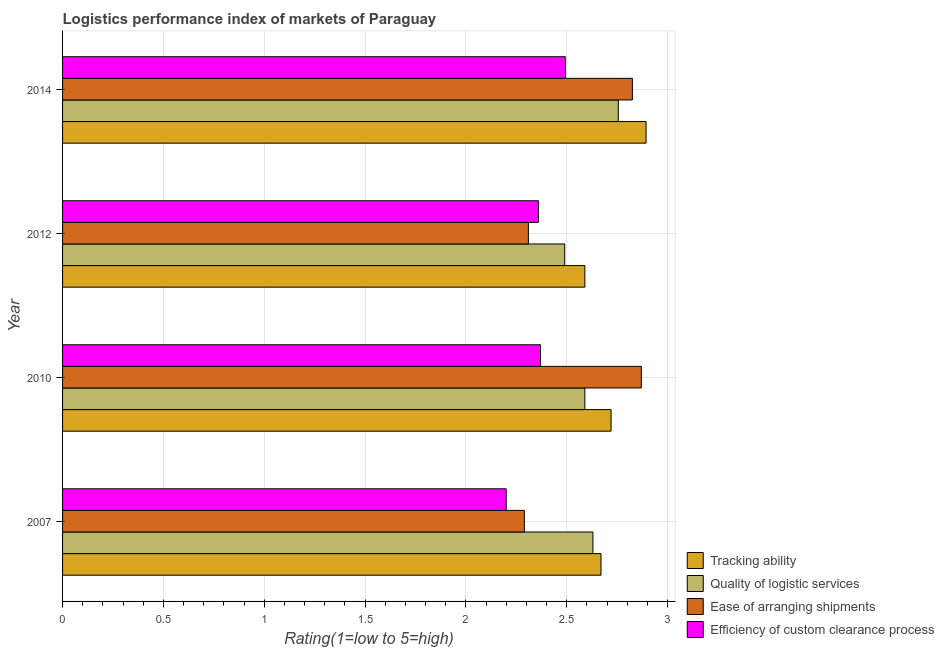How many different coloured bars are there?
Your answer should be compact. 4. Are the number of bars on each tick of the Y-axis equal?
Give a very brief answer. Yes. How many bars are there on the 3rd tick from the top?
Offer a very short reply. 4. How many bars are there on the 2nd tick from the bottom?
Your answer should be compact. 4. What is the label of the 4th group of bars from the top?
Ensure brevity in your answer.  2007. What is the lpi rating of quality of logistic services in 2014?
Your response must be concise. 2.76. Across all years, what is the maximum lpi rating of tracking ability?
Your answer should be very brief. 2.89. Across all years, what is the minimum lpi rating of ease of arranging shipments?
Give a very brief answer. 2.29. In which year was the lpi rating of quality of logistic services minimum?
Give a very brief answer. 2012. What is the total lpi rating of quality of logistic services in the graph?
Your response must be concise. 10.47. What is the difference between the lpi rating of ease of arranging shipments in 2012 and that in 2014?
Your answer should be very brief. -0.52. What is the difference between the lpi rating of quality of logistic services in 2012 and the lpi rating of ease of arranging shipments in 2007?
Make the answer very short. 0.2. What is the average lpi rating of tracking ability per year?
Your response must be concise. 2.72. In the year 2012, what is the difference between the lpi rating of ease of arranging shipments and lpi rating of quality of logistic services?
Your response must be concise. -0.18. In how many years, is the lpi rating of ease of arranging shipments greater than 0.30000000000000004 ?
Your answer should be compact. 4. What is the ratio of the lpi rating of ease of arranging shipments in 2007 to that in 2014?
Give a very brief answer. 0.81. Is the difference between the lpi rating of tracking ability in 2007 and 2012 greater than the difference between the lpi rating of ease of arranging shipments in 2007 and 2012?
Provide a succinct answer. Yes. What is the difference between the highest and the second highest lpi rating of tracking ability?
Your answer should be very brief. 0.17. What is the difference between the highest and the lowest lpi rating of ease of arranging shipments?
Provide a succinct answer. 0.58. In how many years, is the lpi rating of ease of arranging shipments greater than the average lpi rating of ease of arranging shipments taken over all years?
Give a very brief answer. 2. Is it the case that in every year, the sum of the lpi rating of ease of arranging shipments and lpi rating of efficiency of custom clearance process is greater than the sum of lpi rating of quality of logistic services and lpi rating of tracking ability?
Your response must be concise. No. What does the 4th bar from the top in 2010 represents?
Ensure brevity in your answer.  Tracking ability. What does the 1st bar from the bottom in 2012 represents?
Provide a short and direct response. Tracking ability. How many bars are there?
Give a very brief answer. 16. Are all the bars in the graph horizontal?
Your answer should be very brief. Yes. How many years are there in the graph?
Your answer should be very brief. 4. How many legend labels are there?
Make the answer very short. 4. What is the title of the graph?
Ensure brevity in your answer.  Logistics performance index of markets of Paraguay. Does "Regional development banks" appear as one of the legend labels in the graph?
Your response must be concise. No. What is the label or title of the X-axis?
Give a very brief answer. Rating(1=low to 5=high). What is the label or title of the Y-axis?
Provide a succinct answer. Year. What is the Rating(1=low to 5=high) in Tracking ability in 2007?
Offer a very short reply. 2.67. What is the Rating(1=low to 5=high) in Quality of logistic services in 2007?
Offer a very short reply. 2.63. What is the Rating(1=low to 5=high) of Ease of arranging shipments in 2007?
Make the answer very short. 2.29. What is the Rating(1=low to 5=high) in Tracking ability in 2010?
Offer a terse response. 2.72. What is the Rating(1=low to 5=high) in Quality of logistic services in 2010?
Give a very brief answer. 2.59. What is the Rating(1=low to 5=high) in Ease of arranging shipments in 2010?
Your answer should be compact. 2.87. What is the Rating(1=low to 5=high) in Efficiency of custom clearance process in 2010?
Ensure brevity in your answer.  2.37. What is the Rating(1=low to 5=high) of Tracking ability in 2012?
Offer a very short reply. 2.59. What is the Rating(1=low to 5=high) of Quality of logistic services in 2012?
Offer a terse response. 2.49. What is the Rating(1=low to 5=high) of Ease of arranging shipments in 2012?
Make the answer very short. 2.31. What is the Rating(1=low to 5=high) of Efficiency of custom clearance process in 2012?
Make the answer very short. 2.36. What is the Rating(1=low to 5=high) of Tracking ability in 2014?
Your answer should be very brief. 2.89. What is the Rating(1=low to 5=high) of Quality of logistic services in 2014?
Your answer should be compact. 2.76. What is the Rating(1=low to 5=high) of Ease of arranging shipments in 2014?
Your response must be concise. 2.83. What is the Rating(1=low to 5=high) of Efficiency of custom clearance process in 2014?
Offer a terse response. 2.49. Across all years, what is the maximum Rating(1=low to 5=high) in Tracking ability?
Give a very brief answer. 2.89. Across all years, what is the maximum Rating(1=low to 5=high) in Quality of logistic services?
Give a very brief answer. 2.76. Across all years, what is the maximum Rating(1=low to 5=high) in Ease of arranging shipments?
Provide a succinct answer. 2.87. Across all years, what is the maximum Rating(1=low to 5=high) of Efficiency of custom clearance process?
Provide a short and direct response. 2.49. Across all years, what is the minimum Rating(1=low to 5=high) of Tracking ability?
Provide a short and direct response. 2.59. Across all years, what is the minimum Rating(1=low to 5=high) of Quality of logistic services?
Your answer should be very brief. 2.49. Across all years, what is the minimum Rating(1=low to 5=high) of Ease of arranging shipments?
Provide a succinct answer. 2.29. Across all years, what is the minimum Rating(1=low to 5=high) in Efficiency of custom clearance process?
Keep it short and to the point. 2.2. What is the total Rating(1=low to 5=high) of Tracking ability in the graph?
Offer a very short reply. 10.87. What is the total Rating(1=low to 5=high) of Quality of logistic services in the graph?
Ensure brevity in your answer.  10.47. What is the total Rating(1=low to 5=high) of Ease of arranging shipments in the graph?
Provide a succinct answer. 10.3. What is the total Rating(1=low to 5=high) of Efficiency of custom clearance process in the graph?
Ensure brevity in your answer.  9.42. What is the difference between the Rating(1=low to 5=high) of Tracking ability in 2007 and that in 2010?
Provide a succinct answer. -0.05. What is the difference between the Rating(1=low to 5=high) of Quality of logistic services in 2007 and that in 2010?
Give a very brief answer. 0.04. What is the difference between the Rating(1=low to 5=high) in Ease of arranging shipments in 2007 and that in 2010?
Offer a very short reply. -0.58. What is the difference between the Rating(1=low to 5=high) of Efficiency of custom clearance process in 2007 and that in 2010?
Your response must be concise. -0.17. What is the difference between the Rating(1=low to 5=high) of Quality of logistic services in 2007 and that in 2012?
Offer a terse response. 0.14. What is the difference between the Rating(1=low to 5=high) of Ease of arranging shipments in 2007 and that in 2012?
Offer a very short reply. -0.02. What is the difference between the Rating(1=low to 5=high) in Efficiency of custom clearance process in 2007 and that in 2012?
Your answer should be very brief. -0.16. What is the difference between the Rating(1=low to 5=high) of Tracking ability in 2007 and that in 2014?
Your answer should be very brief. -0.22. What is the difference between the Rating(1=low to 5=high) of Quality of logistic services in 2007 and that in 2014?
Your answer should be very brief. -0.13. What is the difference between the Rating(1=low to 5=high) of Ease of arranging shipments in 2007 and that in 2014?
Give a very brief answer. -0.54. What is the difference between the Rating(1=low to 5=high) of Efficiency of custom clearance process in 2007 and that in 2014?
Provide a short and direct response. -0.29. What is the difference between the Rating(1=low to 5=high) of Tracking ability in 2010 and that in 2012?
Offer a very short reply. 0.13. What is the difference between the Rating(1=low to 5=high) of Ease of arranging shipments in 2010 and that in 2012?
Provide a succinct answer. 0.56. What is the difference between the Rating(1=low to 5=high) of Tracking ability in 2010 and that in 2014?
Provide a short and direct response. -0.17. What is the difference between the Rating(1=low to 5=high) of Quality of logistic services in 2010 and that in 2014?
Make the answer very short. -0.17. What is the difference between the Rating(1=low to 5=high) of Ease of arranging shipments in 2010 and that in 2014?
Provide a succinct answer. 0.04. What is the difference between the Rating(1=low to 5=high) of Efficiency of custom clearance process in 2010 and that in 2014?
Keep it short and to the point. -0.12. What is the difference between the Rating(1=low to 5=high) in Tracking ability in 2012 and that in 2014?
Keep it short and to the point. -0.3. What is the difference between the Rating(1=low to 5=high) in Quality of logistic services in 2012 and that in 2014?
Provide a succinct answer. -0.27. What is the difference between the Rating(1=low to 5=high) of Ease of arranging shipments in 2012 and that in 2014?
Offer a very short reply. -0.52. What is the difference between the Rating(1=low to 5=high) of Efficiency of custom clearance process in 2012 and that in 2014?
Provide a succinct answer. -0.13. What is the difference between the Rating(1=low to 5=high) of Tracking ability in 2007 and the Rating(1=low to 5=high) of Quality of logistic services in 2010?
Give a very brief answer. 0.08. What is the difference between the Rating(1=low to 5=high) of Quality of logistic services in 2007 and the Rating(1=low to 5=high) of Ease of arranging shipments in 2010?
Provide a succinct answer. -0.24. What is the difference between the Rating(1=low to 5=high) in Quality of logistic services in 2007 and the Rating(1=low to 5=high) in Efficiency of custom clearance process in 2010?
Provide a succinct answer. 0.26. What is the difference between the Rating(1=low to 5=high) of Ease of arranging shipments in 2007 and the Rating(1=low to 5=high) of Efficiency of custom clearance process in 2010?
Provide a short and direct response. -0.08. What is the difference between the Rating(1=low to 5=high) in Tracking ability in 2007 and the Rating(1=low to 5=high) in Quality of logistic services in 2012?
Keep it short and to the point. 0.18. What is the difference between the Rating(1=low to 5=high) in Tracking ability in 2007 and the Rating(1=low to 5=high) in Ease of arranging shipments in 2012?
Your answer should be very brief. 0.36. What is the difference between the Rating(1=low to 5=high) of Tracking ability in 2007 and the Rating(1=low to 5=high) of Efficiency of custom clearance process in 2012?
Provide a succinct answer. 0.31. What is the difference between the Rating(1=low to 5=high) of Quality of logistic services in 2007 and the Rating(1=low to 5=high) of Ease of arranging shipments in 2012?
Make the answer very short. 0.32. What is the difference between the Rating(1=low to 5=high) of Quality of logistic services in 2007 and the Rating(1=low to 5=high) of Efficiency of custom clearance process in 2012?
Ensure brevity in your answer.  0.27. What is the difference between the Rating(1=low to 5=high) in Ease of arranging shipments in 2007 and the Rating(1=low to 5=high) in Efficiency of custom clearance process in 2012?
Provide a succinct answer. -0.07. What is the difference between the Rating(1=low to 5=high) in Tracking ability in 2007 and the Rating(1=low to 5=high) in Quality of logistic services in 2014?
Give a very brief answer. -0.09. What is the difference between the Rating(1=low to 5=high) of Tracking ability in 2007 and the Rating(1=low to 5=high) of Ease of arranging shipments in 2014?
Offer a terse response. -0.16. What is the difference between the Rating(1=low to 5=high) of Tracking ability in 2007 and the Rating(1=low to 5=high) of Efficiency of custom clearance process in 2014?
Offer a very short reply. 0.18. What is the difference between the Rating(1=low to 5=high) in Quality of logistic services in 2007 and the Rating(1=low to 5=high) in Ease of arranging shipments in 2014?
Offer a terse response. -0.2. What is the difference between the Rating(1=low to 5=high) in Quality of logistic services in 2007 and the Rating(1=low to 5=high) in Efficiency of custom clearance process in 2014?
Provide a short and direct response. 0.14. What is the difference between the Rating(1=low to 5=high) in Ease of arranging shipments in 2007 and the Rating(1=low to 5=high) in Efficiency of custom clearance process in 2014?
Your answer should be very brief. -0.2. What is the difference between the Rating(1=low to 5=high) of Tracking ability in 2010 and the Rating(1=low to 5=high) of Quality of logistic services in 2012?
Provide a succinct answer. 0.23. What is the difference between the Rating(1=low to 5=high) in Tracking ability in 2010 and the Rating(1=low to 5=high) in Ease of arranging shipments in 2012?
Make the answer very short. 0.41. What is the difference between the Rating(1=low to 5=high) of Tracking ability in 2010 and the Rating(1=low to 5=high) of Efficiency of custom clearance process in 2012?
Offer a terse response. 0.36. What is the difference between the Rating(1=low to 5=high) in Quality of logistic services in 2010 and the Rating(1=low to 5=high) in Ease of arranging shipments in 2012?
Keep it short and to the point. 0.28. What is the difference between the Rating(1=low to 5=high) in Quality of logistic services in 2010 and the Rating(1=low to 5=high) in Efficiency of custom clearance process in 2012?
Keep it short and to the point. 0.23. What is the difference between the Rating(1=low to 5=high) of Ease of arranging shipments in 2010 and the Rating(1=low to 5=high) of Efficiency of custom clearance process in 2012?
Your answer should be compact. 0.51. What is the difference between the Rating(1=low to 5=high) in Tracking ability in 2010 and the Rating(1=low to 5=high) in Quality of logistic services in 2014?
Ensure brevity in your answer.  -0.04. What is the difference between the Rating(1=low to 5=high) in Tracking ability in 2010 and the Rating(1=low to 5=high) in Ease of arranging shipments in 2014?
Offer a terse response. -0.11. What is the difference between the Rating(1=low to 5=high) of Tracking ability in 2010 and the Rating(1=low to 5=high) of Efficiency of custom clearance process in 2014?
Offer a very short reply. 0.23. What is the difference between the Rating(1=low to 5=high) in Quality of logistic services in 2010 and the Rating(1=low to 5=high) in Ease of arranging shipments in 2014?
Give a very brief answer. -0.24. What is the difference between the Rating(1=low to 5=high) of Quality of logistic services in 2010 and the Rating(1=low to 5=high) of Efficiency of custom clearance process in 2014?
Provide a succinct answer. 0.1. What is the difference between the Rating(1=low to 5=high) of Ease of arranging shipments in 2010 and the Rating(1=low to 5=high) of Efficiency of custom clearance process in 2014?
Your response must be concise. 0.38. What is the difference between the Rating(1=low to 5=high) in Tracking ability in 2012 and the Rating(1=low to 5=high) in Quality of logistic services in 2014?
Make the answer very short. -0.17. What is the difference between the Rating(1=low to 5=high) in Tracking ability in 2012 and the Rating(1=low to 5=high) in Ease of arranging shipments in 2014?
Offer a terse response. -0.24. What is the difference between the Rating(1=low to 5=high) of Tracking ability in 2012 and the Rating(1=low to 5=high) of Efficiency of custom clearance process in 2014?
Your response must be concise. 0.1. What is the difference between the Rating(1=low to 5=high) in Quality of logistic services in 2012 and the Rating(1=low to 5=high) in Ease of arranging shipments in 2014?
Give a very brief answer. -0.34. What is the difference between the Rating(1=low to 5=high) in Quality of logistic services in 2012 and the Rating(1=low to 5=high) in Efficiency of custom clearance process in 2014?
Ensure brevity in your answer.  -0. What is the difference between the Rating(1=low to 5=high) of Ease of arranging shipments in 2012 and the Rating(1=low to 5=high) of Efficiency of custom clearance process in 2014?
Provide a succinct answer. -0.18. What is the average Rating(1=low to 5=high) in Tracking ability per year?
Provide a succinct answer. 2.72. What is the average Rating(1=low to 5=high) in Quality of logistic services per year?
Provide a short and direct response. 2.62. What is the average Rating(1=low to 5=high) of Ease of arranging shipments per year?
Offer a terse response. 2.57. What is the average Rating(1=low to 5=high) of Efficiency of custom clearance process per year?
Offer a terse response. 2.36. In the year 2007, what is the difference between the Rating(1=low to 5=high) in Tracking ability and Rating(1=low to 5=high) in Quality of logistic services?
Your response must be concise. 0.04. In the year 2007, what is the difference between the Rating(1=low to 5=high) of Tracking ability and Rating(1=low to 5=high) of Ease of arranging shipments?
Your response must be concise. 0.38. In the year 2007, what is the difference between the Rating(1=low to 5=high) in Tracking ability and Rating(1=low to 5=high) in Efficiency of custom clearance process?
Offer a very short reply. 0.47. In the year 2007, what is the difference between the Rating(1=low to 5=high) in Quality of logistic services and Rating(1=low to 5=high) in Ease of arranging shipments?
Ensure brevity in your answer.  0.34. In the year 2007, what is the difference between the Rating(1=low to 5=high) of Quality of logistic services and Rating(1=low to 5=high) of Efficiency of custom clearance process?
Provide a succinct answer. 0.43. In the year 2007, what is the difference between the Rating(1=low to 5=high) in Ease of arranging shipments and Rating(1=low to 5=high) in Efficiency of custom clearance process?
Provide a succinct answer. 0.09. In the year 2010, what is the difference between the Rating(1=low to 5=high) of Tracking ability and Rating(1=low to 5=high) of Quality of logistic services?
Your answer should be very brief. 0.13. In the year 2010, what is the difference between the Rating(1=low to 5=high) in Tracking ability and Rating(1=low to 5=high) in Ease of arranging shipments?
Provide a short and direct response. -0.15. In the year 2010, what is the difference between the Rating(1=low to 5=high) in Tracking ability and Rating(1=low to 5=high) in Efficiency of custom clearance process?
Offer a terse response. 0.35. In the year 2010, what is the difference between the Rating(1=low to 5=high) in Quality of logistic services and Rating(1=low to 5=high) in Ease of arranging shipments?
Your answer should be very brief. -0.28. In the year 2010, what is the difference between the Rating(1=low to 5=high) of Quality of logistic services and Rating(1=low to 5=high) of Efficiency of custom clearance process?
Your answer should be compact. 0.22. In the year 2010, what is the difference between the Rating(1=low to 5=high) of Ease of arranging shipments and Rating(1=low to 5=high) of Efficiency of custom clearance process?
Provide a short and direct response. 0.5. In the year 2012, what is the difference between the Rating(1=low to 5=high) of Tracking ability and Rating(1=low to 5=high) of Ease of arranging shipments?
Your answer should be very brief. 0.28. In the year 2012, what is the difference between the Rating(1=low to 5=high) in Tracking ability and Rating(1=low to 5=high) in Efficiency of custom clearance process?
Ensure brevity in your answer.  0.23. In the year 2012, what is the difference between the Rating(1=low to 5=high) in Quality of logistic services and Rating(1=low to 5=high) in Ease of arranging shipments?
Ensure brevity in your answer.  0.18. In the year 2012, what is the difference between the Rating(1=low to 5=high) in Quality of logistic services and Rating(1=low to 5=high) in Efficiency of custom clearance process?
Offer a very short reply. 0.13. In the year 2014, what is the difference between the Rating(1=low to 5=high) in Tracking ability and Rating(1=low to 5=high) in Quality of logistic services?
Give a very brief answer. 0.14. In the year 2014, what is the difference between the Rating(1=low to 5=high) of Tracking ability and Rating(1=low to 5=high) of Ease of arranging shipments?
Provide a short and direct response. 0.07. In the year 2014, what is the difference between the Rating(1=low to 5=high) in Tracking ability and Rating(1=low to 5=high) in Efficiency of custom clearance process?
Your response must be concise. 0.4. In the year 2014, what is the difference between the Rating(1=low to 5=high) of Quality of logistic services and Rating(1=low to 5=high) of Ease of arranging shipments?
Make the answer very short. -0.07. In the year 2014, what is the difference between the Rating(1=low to 5=high) in Quality of logistic services and Rating(1=low to 5=high) in Efficiency of custom clearance process?
Make the answer very short. 0.26. In the year 2014, what is the difference between the Rating(1=low to 5=high) of Ease of arranging shipments and Rating(1=low to 5=high) of Efficiency of custom clearance process?
Ensure brevity in your answer.  0.33. What is the ratio of the Rating(1=low to 5=high) of Tracking ability in 2007 to that in 2010?
Provide a succinct answer. 0.98. What is the ratio of the Rating(1=low to 5=high) of Quality of logistic services in 2007 to that in 2010?
Give a very brief answer. 1.02. What is the ratio of the Rating(1=low to 5=high) in Ease of arranging shipments in 2007 to that in 2010?
Keep it short and to the point. 0.8. What is the ratio of the Rating(1=low to 5=high) in Efficiency of custom clearance process in 2007 to that in 2010?
Provide a succinct answer. 0.93. What is the ratio of the Rating(1=low to 5=high) in Tracking ability in 2007 to that in 2012?
Offer a very short reply. 1.03. What is the ratio of the Rating(1=low to 5=high) in Quality of logistic services in 2007 to that in 2012?
Keep it short and to the point. 1.06. What is the ratio of the Rating(1=low to 5=high) of Efficiency of custom clearance process in 2007 to that in 2012?
Provide a short and direct response. 0.93. What is the ratio of the Rating(1=low to 5=high) of Tracking ability in 2007 to that in 2014?
Provide a short and direct response. 0.92. What is the ratio of the Rating(1=low to 5=high) in Quality of logistic services in 2007 to that in 2014?
Provide a succinct answer. 0.95. What is the ratio of the Rating(1=low to 5=high) in Ease of arranging shipments in 2007 to that in 2014?
Your answer should be compact. 0.81. What is the ratio of the Rating(1=low to 5=high) in Efficiency of custom clearance process in 2007 to that in 2014?
Provide a succinct answer. 0.88. What is the ratio of the Rating(1=low to 5=high) in Tracking ability in 2010 to that in 2012?
Provide a succinct answer. 1.05. What is the ratio of the Rating(1=low to 5=high) of Quality of logistic services in 2010 to that in 2012?
Provide a short and direct response. 1.04. What is the ratio of the Rating(1=low to 5=high) in Ease of arranging shipments in 2010 to that in 2012?
Keep it short and to the point. 1.24. What is the ratio of the Rating(1=low to 5=high) of Quality of logistic services in 2010 to that in 2014?
Provide a succinct answer. 0.94. What is the ratio of the Rating(1=low to 5=high) of Ease of arranging shipments in 2010 to that in 2014?
Your answer should be very brief. 1.02. What is the ratio of the Rating(1=low to 5=high) in Efficiency of custom clearance process in 2010 to that in 2014?
Provide a succinct answer. 0.95. What is the ratio of the Rating(1=low to 5=high) in Tracking ability in 2012 to that in 2014?
Keep it short and to the point. 0.9. What is the ratio of the Rating(1=low to 5=high) in Quality of logistic services in 2012 to that in 2014?
Provide a succinct answer. 0.9. What is the ratio of the Rating(1=low to 5=high) of Ease of arranging shipments in 2012 to that in 2014?
Ensure brevity in your answer.  0.82. What is the ratio of the Rating(1=low to 5=high) in Efficiency of custom clearance process in 2012 to that in 2014?
Offer a terse response. 0.95. What is the difference between the highest and the second highest Rating(1=low to 5=high) of Tracking ability?
Provide a short and direct response. 0.17. What is the difference between the highest and the second highest Rating(1=low to 5=high) of Quality of logistic services?
Provide a succinct answer. 0.13. What is the difference between the highest and the second highest Rating(1=low to 5=high) in Ease of arranging shipments?
Your answer should be very brief. 0.04. What is the difference between the highest and the second highest Rating(1=low to 5=high) in Efficiency of custom clearance process?
Provide a succinct answer. 0.12. What is the difference between the highest and the lowest Rating(1=low to 5=high) in Tracking ability?
Provide a short and direct response. 0.3. What is the difference between the highest and the lowest Rating(1=low to 5=high) in Quality of logistic services?
Offer a terse response. 0.27. What is the difference between the highest and the lowest Rating(1=low to 5=high) in Ease of arranging shipments?
Ensure brevity in your answer.  0.58. What is the difference between the highest and the lowest Rating(1=low to 5=high) of Efficiency of custom clearance process?
Provide a short and direct response. 0.29. 